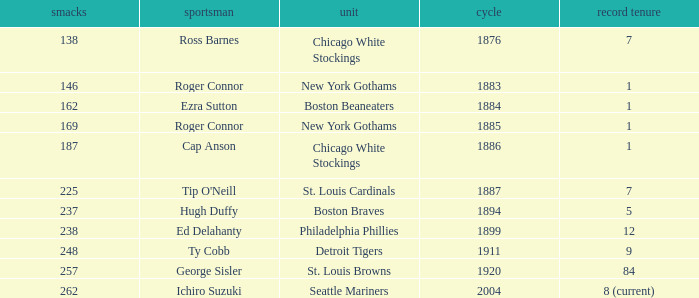Name the least hits for year less than 1920 and player of ed delahanty 238.0. 